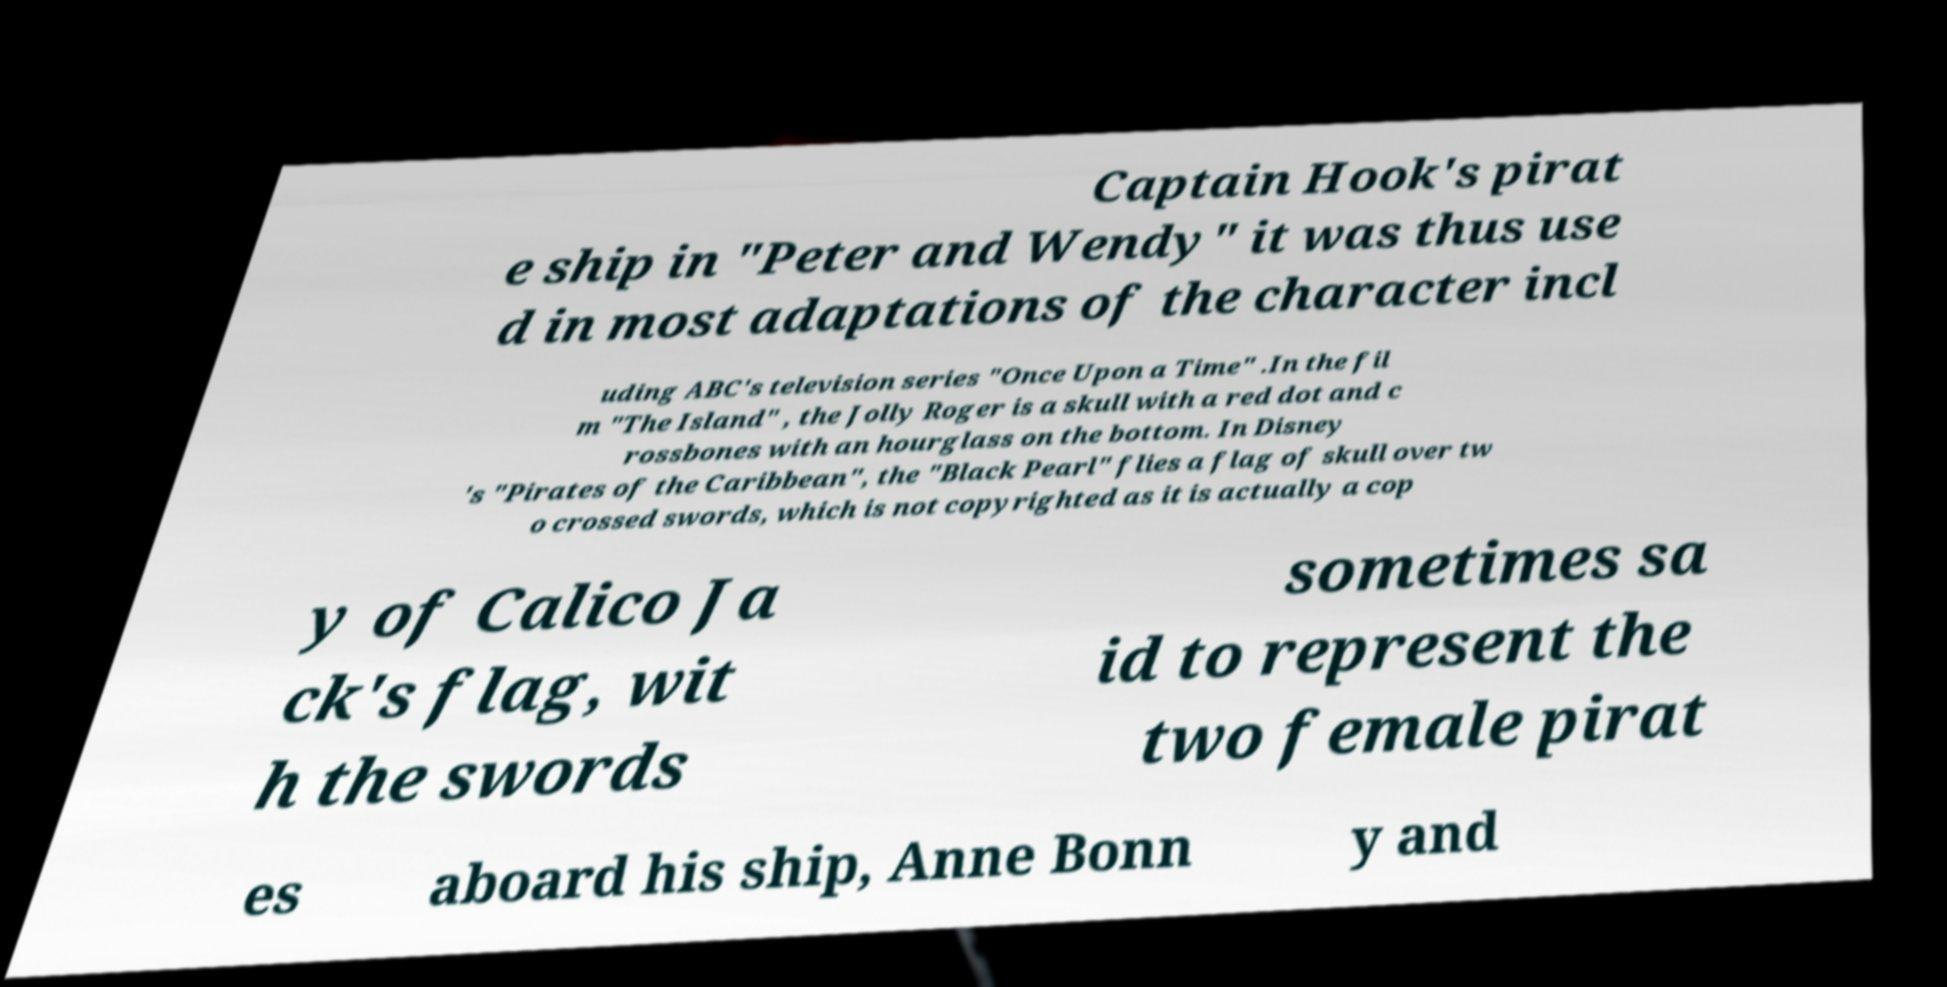There's text embedded in this image that I need extracted. Can you transcribe it verbatim? Captain Hook's pirat e ship in "Peter and Wendy" it was thus use d in most adaptations of the character incl uding ABC's television series "Once Upon a Time" .In the fil m "The Island" , the Jolly Roger is a skull with a red dot and c rossbones with an hourglass on the bottom. In Disney 's "Pirates of the Caribbean", the "Black Pearl" flies a flag of skull over tw o crossed swords, which is not copyrighted as it is actually a cop y of Calico Ja ck's flag, wit h the swords sometimes sa id to represent the two female pirat es aboard his ship, Anne Bonn y and 